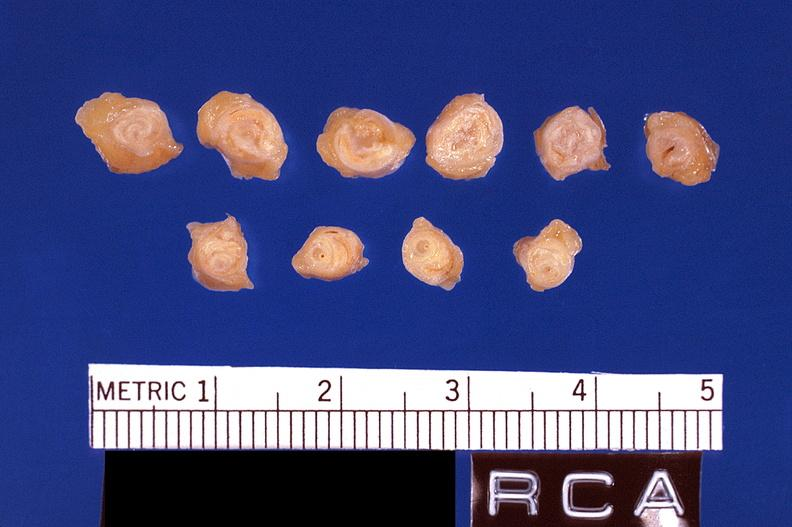does this image show atherosclerosis, right coronary artery?
Answer the question using a single word or phrase. Yes 